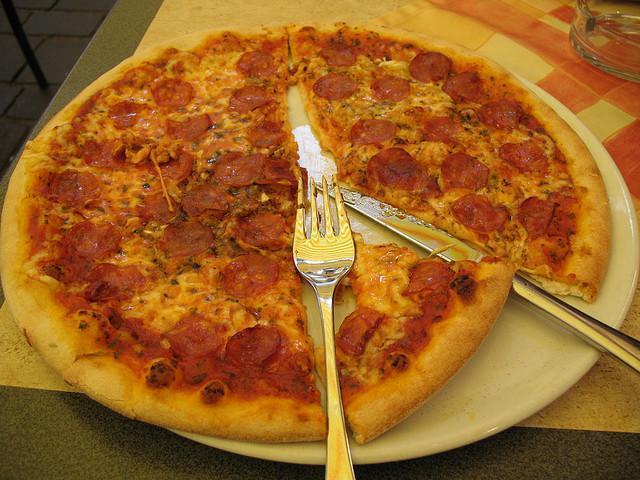How many pizzas can be seen?
Give a very brief answer. 2. How many forks are in the picture?
Give a very brief answer. 1. How many knives can be seen?
Give a very brief answer. 1. How many vases are there?
Give a very brief answer. 0. 